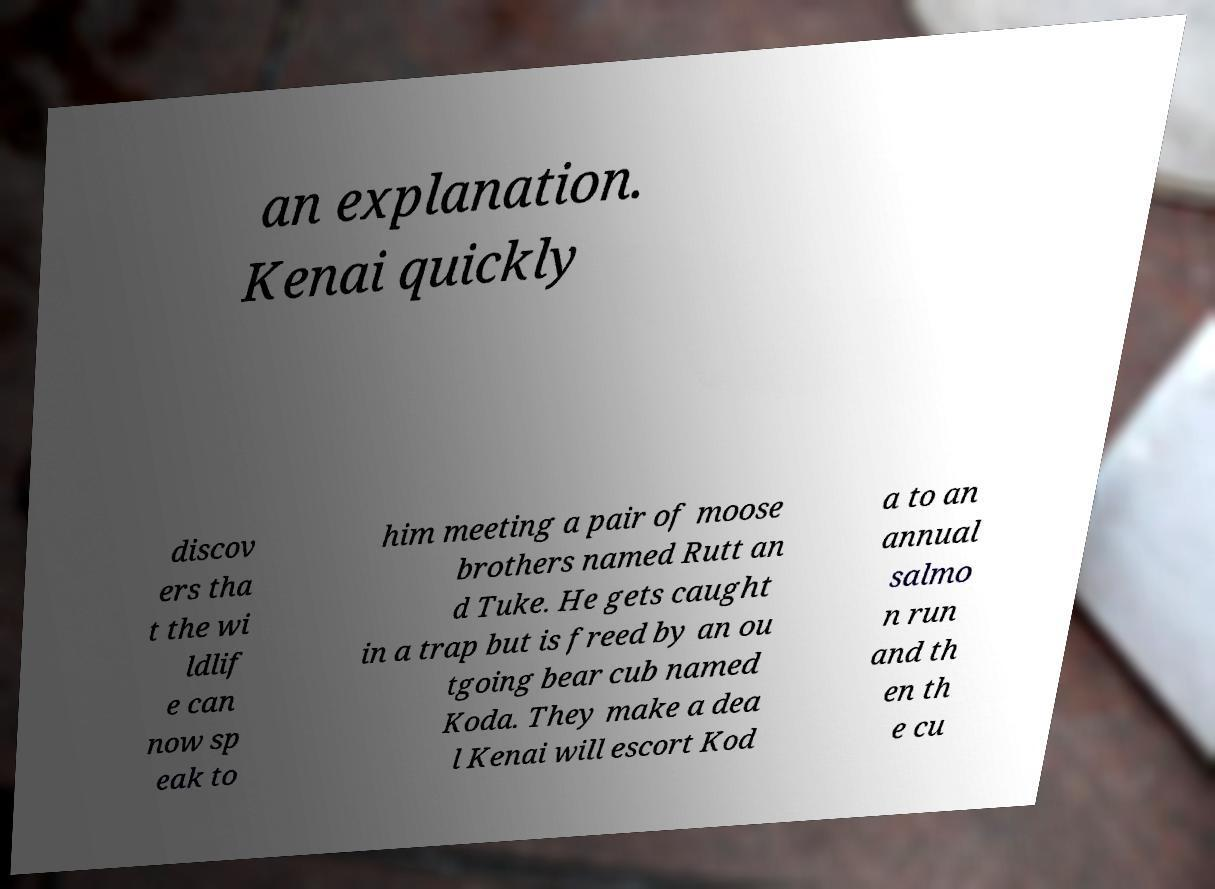Could you extract and type out the text from this image? an explanation. Kenai quickly discov ers tha t the wi ldlif e can now sp eak to him meeting a pair of moose brothers named Rutt an d Tuke. He gets caught in a trap but is freed by an ou tgoing bear cub named Koda. They make a dea l Kenai will escort Kod a to an annual salmo n run and th en th e cu 